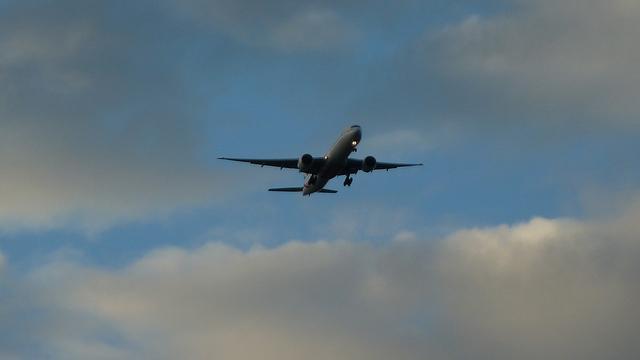How many planes have propellers?
Give a very brief answer. 1. How many airplanes are in the picture?
Give a very brief answer. 1. How many sheep are on the rock?
Give a very brief answer. 0. 